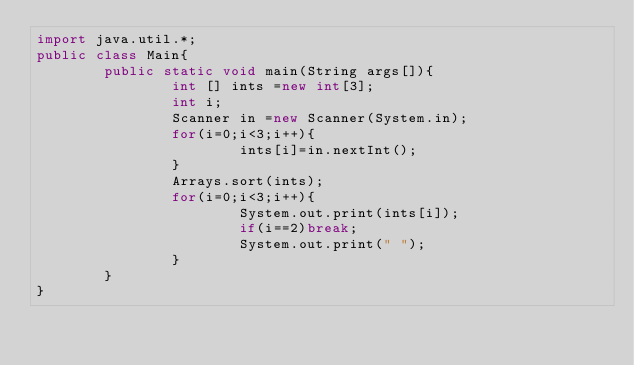Convert code to text. <code><loc_0><loc_0><loc_500><loc_500><_Java_>import java.util.*;
public class Main{
        public static void main(String args[]){
                int [] ints =new int[3];
                int i;
                Scanner in =new Scanner(System.in);
                for(i=0;i<3;i++){
                        ints[i]=in.nextInt();
                }
                Arrays.sort(ints);
                for(i=0;i<3;i++){
                        System.out.print(ints[i]);
                        if(i==2)break;
                        System.out.print(" ");
                }
        }
}</code> 